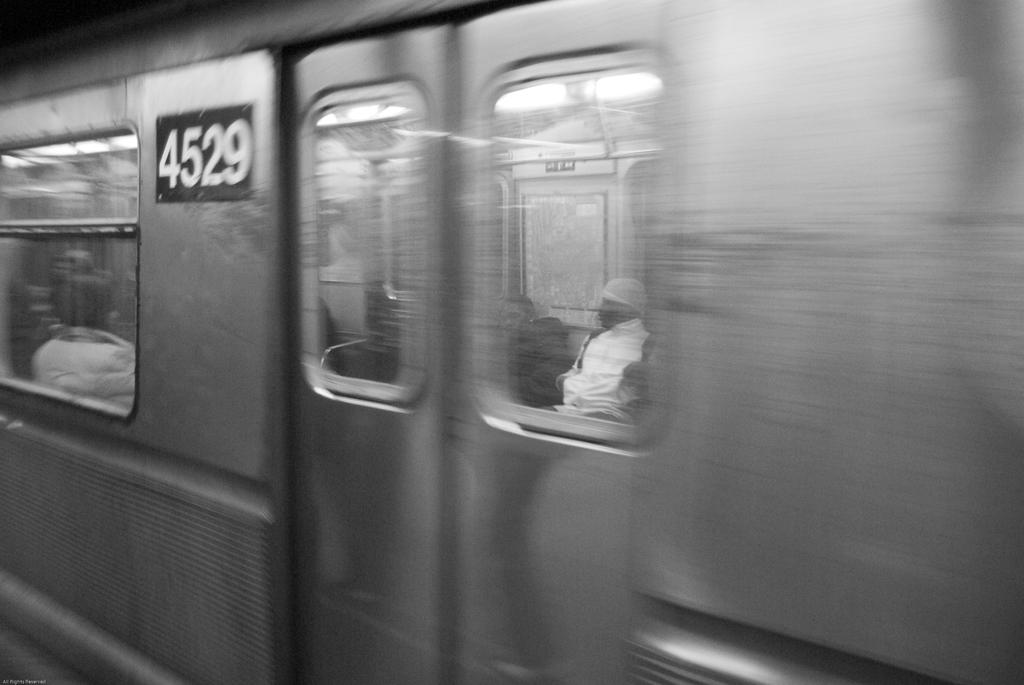<image>
Create a compact narrative representing the image presented. a subway train in black and white with the numbers 4529 visible 